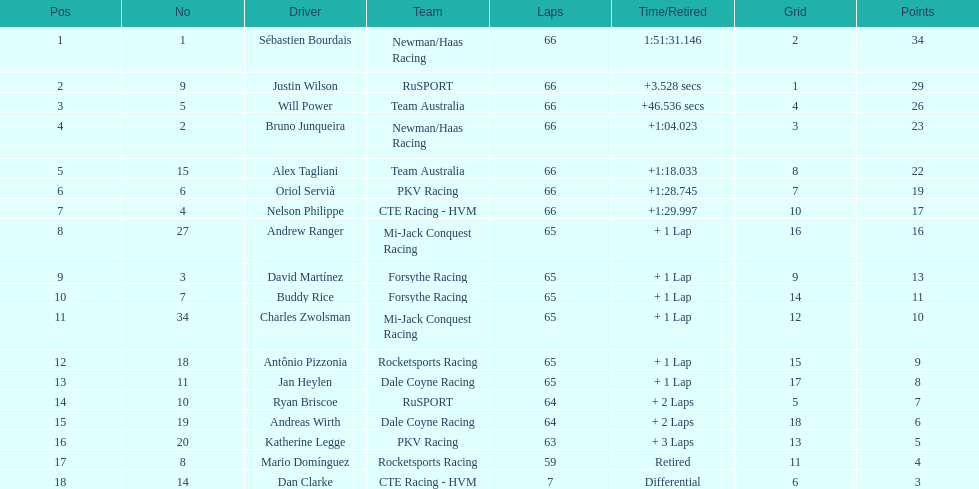At the 2006 gran premio telmex, who ended up in the last position? Dan Clarke. 